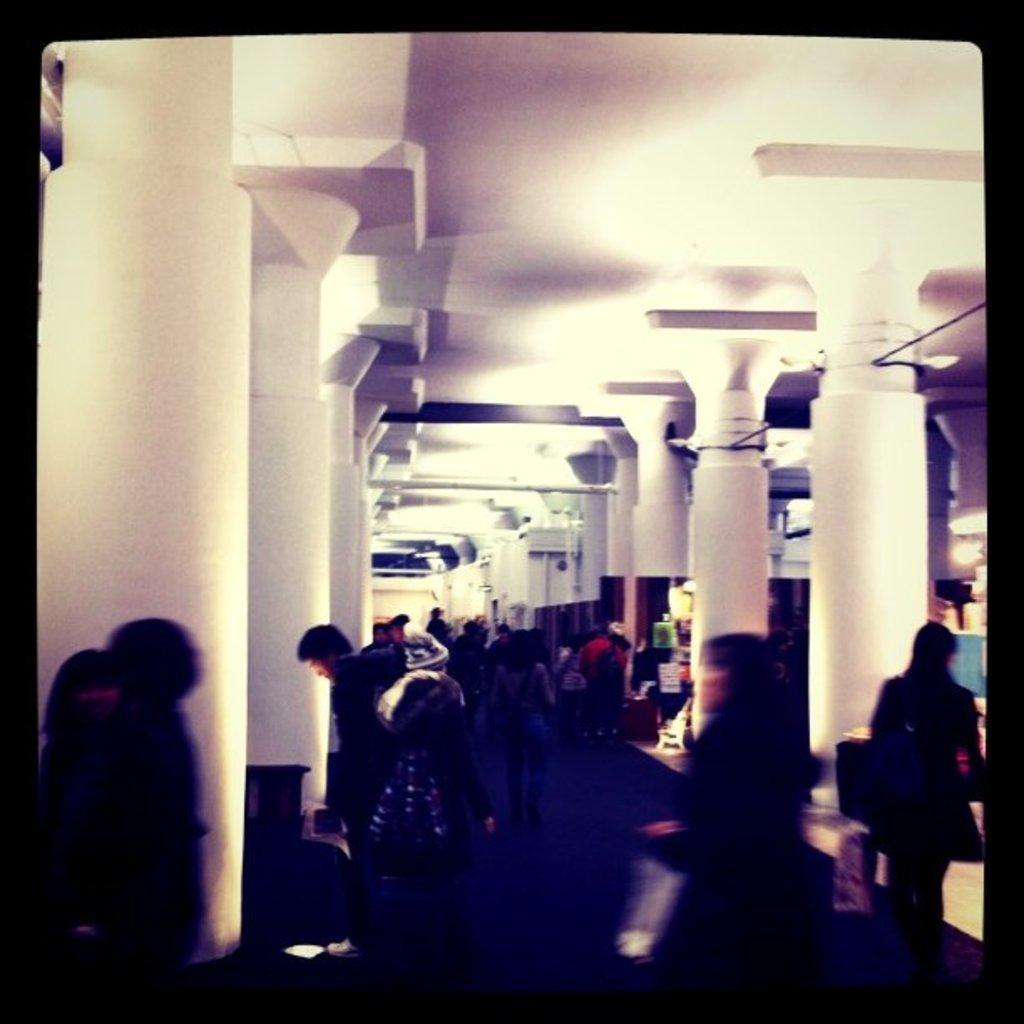How would you summarize this image in a sentence or two? In this picture we can see some people are walking inside of the building and some pillories. 